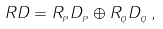Convert formula to latex. <formula><loc_0><loc_0><loc_500><loc_500>R D = R _ { _ { P } } D _ { _ { P } } \oplus R _ { _ { Q } } D _ { _ { Q } } \, ,</formula> 